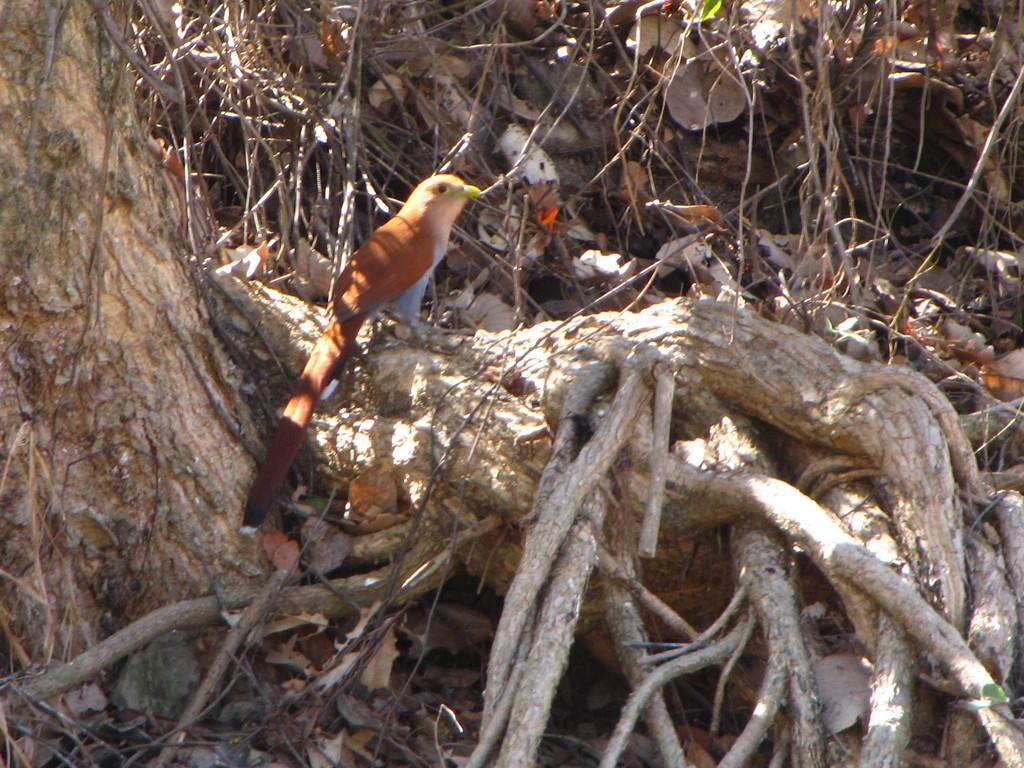What type of animal can be seen in the image? There is a bird in the image. Where is the bird located? The bird is standing on a tree trunk. What can be seen in the background of the image? There are sticks and dried leaves visible in the background. What type of tooth can be seen in the image? There is no tooth present in the image; it features a bird standing on a tree trunk with sticks and dried leaves in the background. 